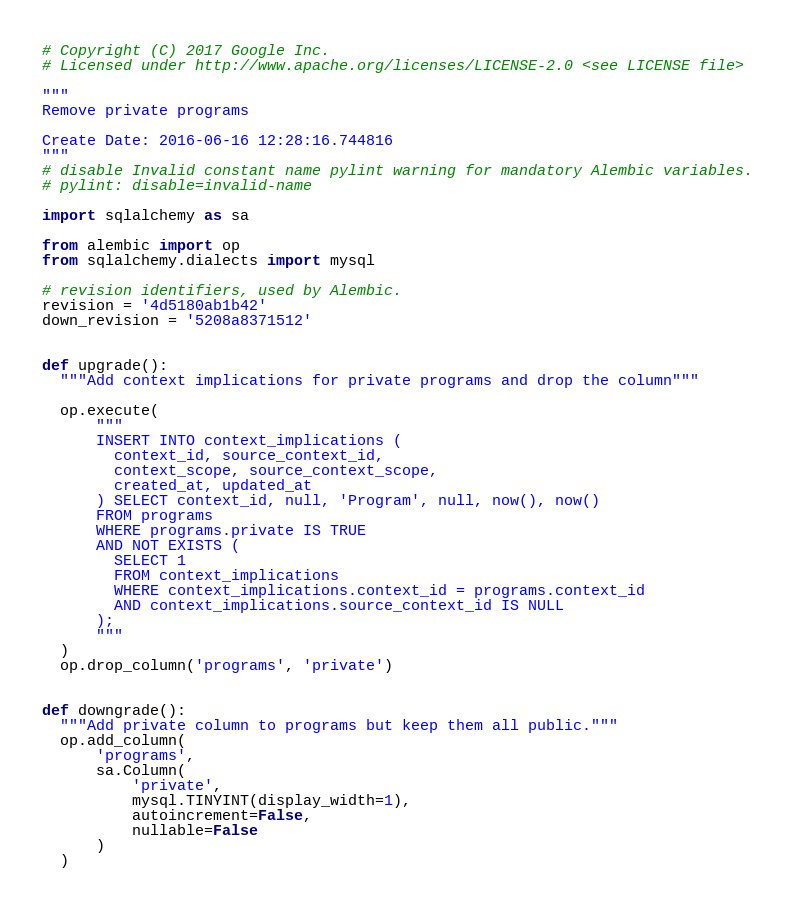<code> <loc_0><loc_0><loc_500><loc_500><_Python_># Copyright (C) 2017 Google Inc.
# Licensed under http://www.apache.org/licenses/LICENSE-2.0 <see LICENSE file>

"""
Remove private programs

Create Date: 2016-06-16 12:28:16.744816
"""
# disable Invalid constant name pylint warning for mandatory Alembic variables.
# pylint: disable=invalid-name

import sqlalchemy as sa

from alembic import op
from sqlalchemy.dialects import mysql

# revision identifiers, used by Alembic.
revision = '4d5180ab1b42'
down_revision = '5208a8371512'


def upgrade():
  """Add context implications for private programs and drop the column"""

  op.execute(
      """
      INSERT INTO context_implications (
        context_id, source_context_id,
        context_scope, source_context_scope,
        created_at, updated_at
      ) SELECT context_id, null, 'Program', null, now(), now()
      FROM programs
      WHERE programs.private IS TRUE
      AND NOT EXISTS (
        SELECT 1
        FROM context_implications
        WHERE context_implications.context_id = programs.context_id
        AND context_implications.source_context_id IS NULL
      );
      """
  )
  op.drop_column('programs', 'private')


def downgrade():
  """Add private column to programs but keep them all public."""
  op.add_column(
      'programs',
      sa.Column(
          'private',
          mysql.TINYINT(display_width=1),
          autoincrement=False,
          nullable=False
      )
  )
</code> 